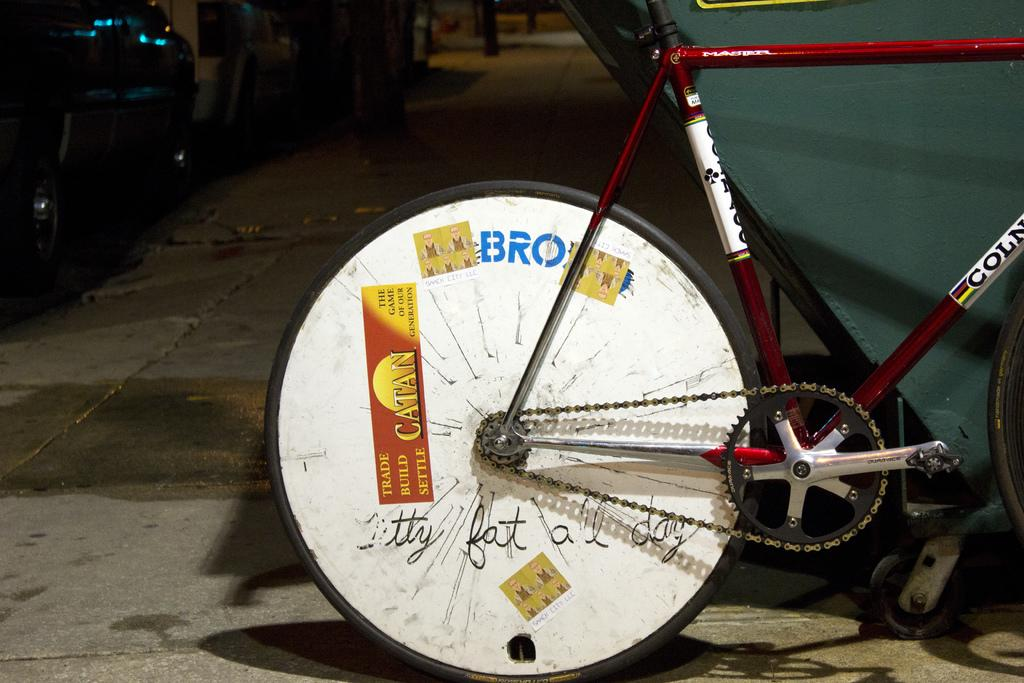What is the main object on the ground in the image? There is a bicycle on the ground in the image. What is the object with wheels behind the bicycle? The object with wheels behind the bicycle is not specified in the facts, but it is mentioned as being present. What can be seen on the left side of the image? There are vehicles on the ground and other objects present on the left side of the image. How does the uncle interact with the bushes in the image? There is no mention of an uncle or bushes in the image, so it is not possible to answer this question. 